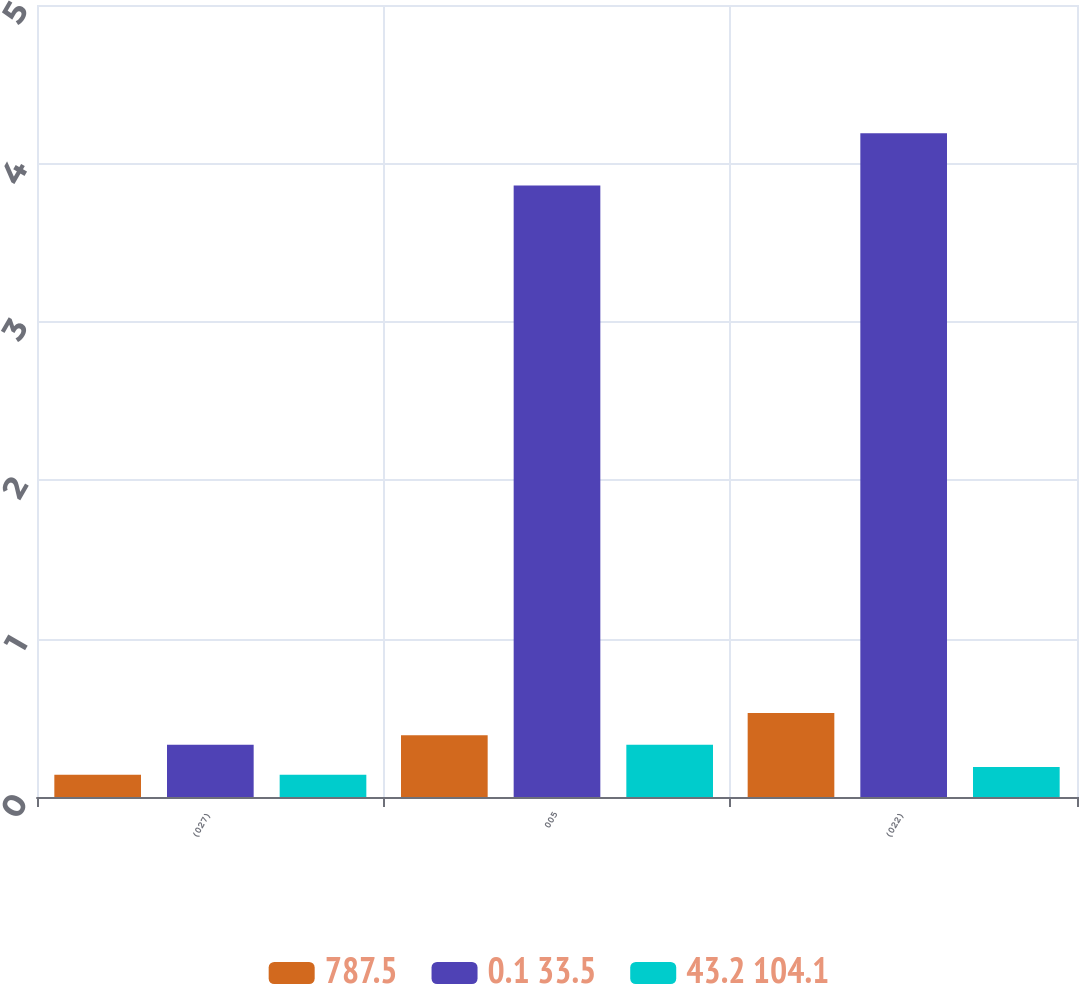Convert chart to OTSL. <chart><loc_0><loc_0><loc_500><loc_500><stacked_bar_chart><ecel><fcel>(027)<fcel>005<fcel>(022)<nl><fcel>787.5<fcel>0.14<fcel>0.39<fcel>0.53<nl><fcel>0.1 33.5<fcel>0.33<fcel>3.86<fcel>4.19<nl><fcel>43.2 104.1<fcel>0.14<fcel>0.33<fcel>0.19<nl></chart> 